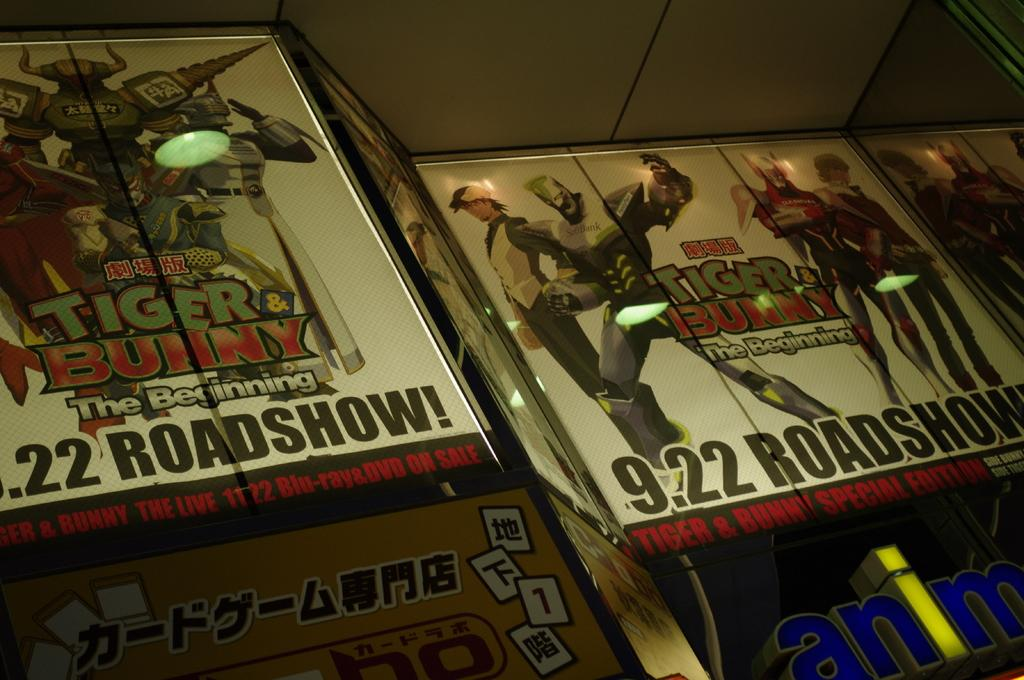<image>
Relay a brief, clear account of the picture shown. Two posters show the Tiger and Bunny anime series comes out on September 22nd. 